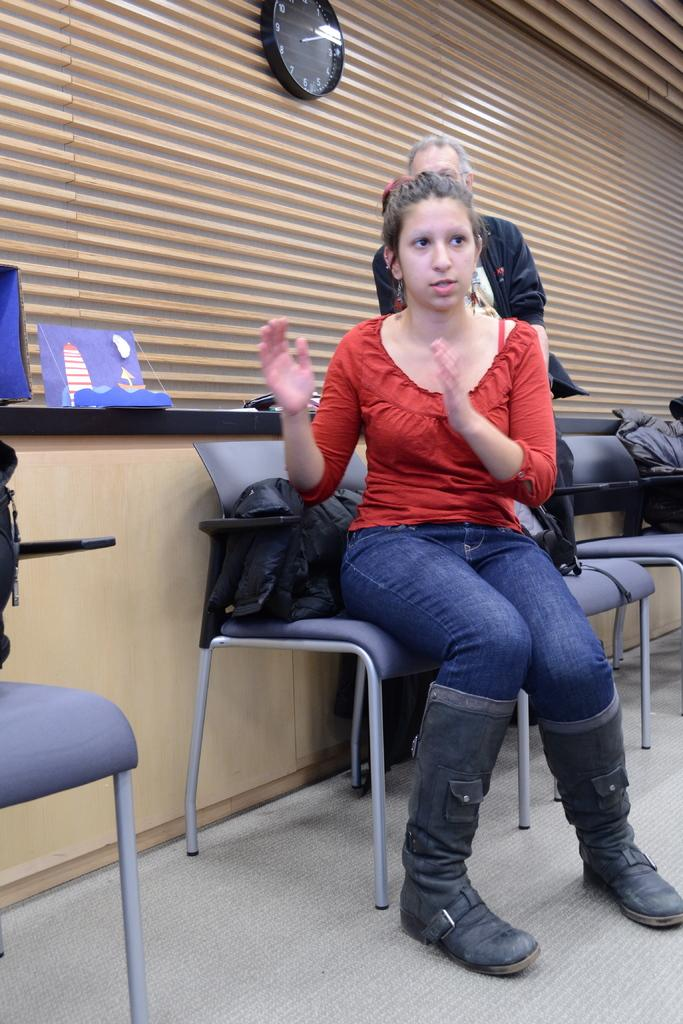What is the woman in the image doing? The woman is sitting on a chair and talking in the image. Can you describe the position of the person in the image? There is a person leaning against a wall in the image. What can be seen on the wall in the image? The wall has some items on it, including a watch. What book is the woman reading in the image? There is no book present in the image; the woman is talking while sitting on a chair. 